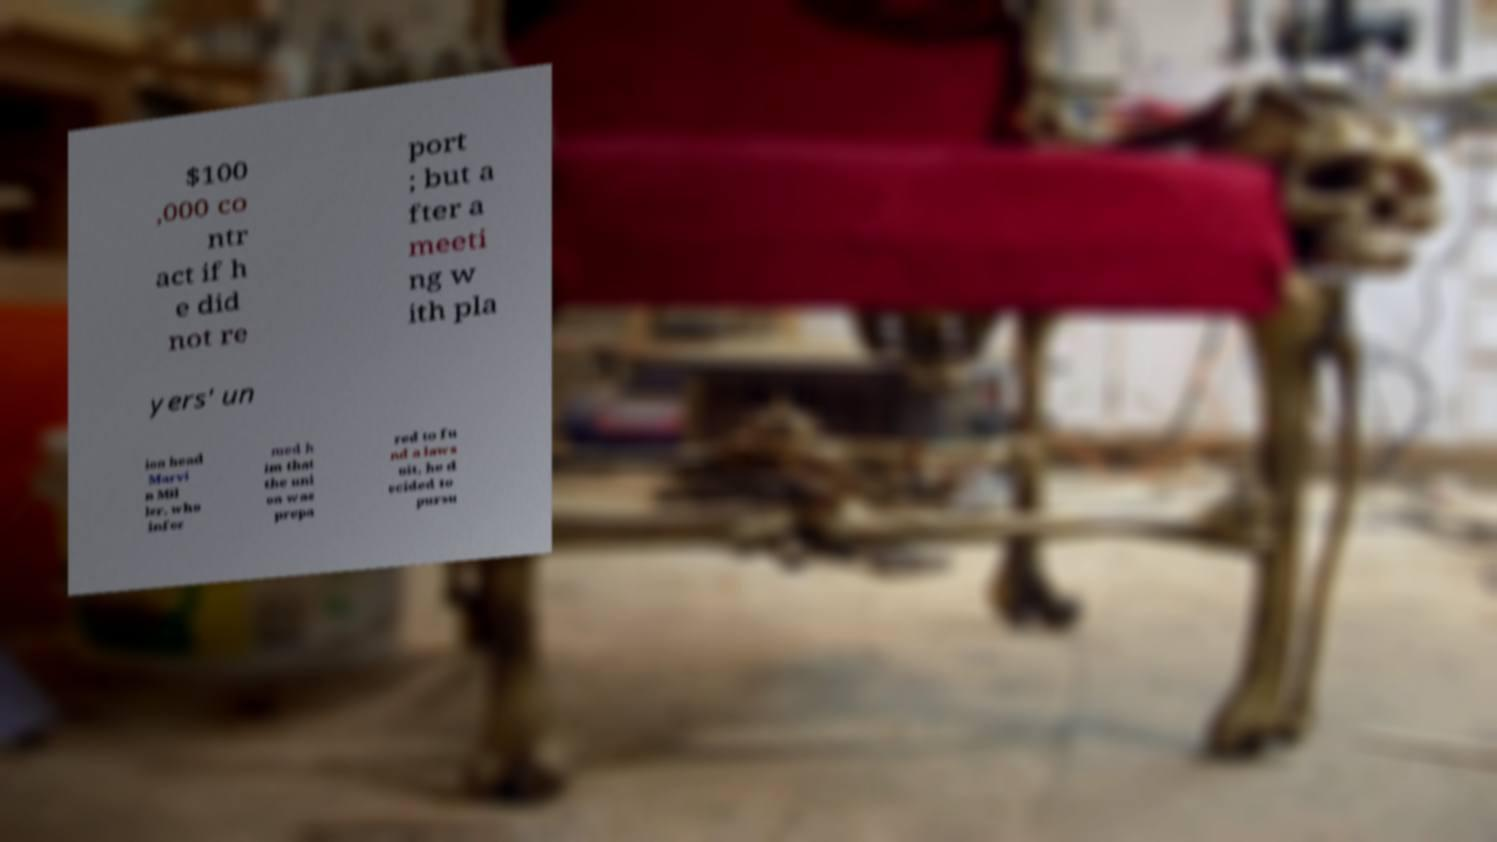What messages or text are displayed in this image? I need them in a readable, typed format. $100 ,000 co ntr act if h e did not re port ; but a fter a meeti ng w ith pla yers' un ion head Marvi n Mil ler, who infor med h im that the uni on was prepa red to fu nd a laws uit, he d ecided to pursu 